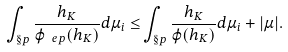<formula> <loc_0><loc_0><loc_500><loc_500>\int _ { \S p } \frac { h _ { K } } { \varphi _ { \ e p } ( h _ { K } ) } d \mu _ { i } \leq & \int _ { \S p } \frac { h _ { K } } { \varphi ( h _ { K } ) } d \mu _ { i } + | \mu | .</formula> 